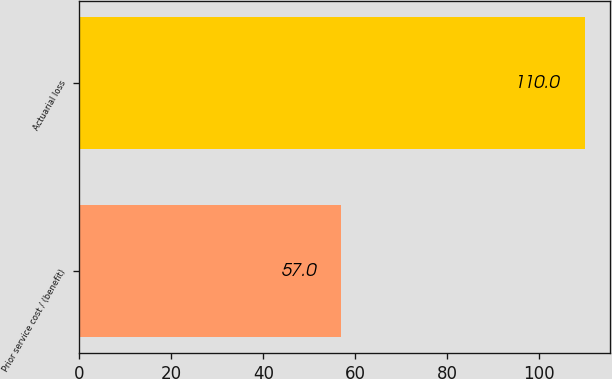<chart> <loc_0><loc_0><loc_500><loc_500><bar_chart><fcel>Prior service cost / (benefit)<fcel>Actuarial loss<nl><fcel>57<fcel>110<nl></chart> 